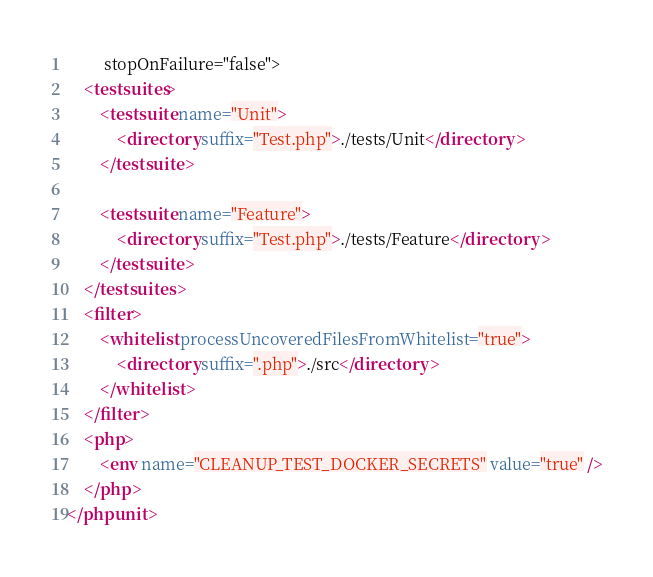Convert code to text. <code><loc_0><loc_0><loc_500><loc_500><_XML_>         stopOnFailure="false">
    <testsuites>
        <testsuite name="Unit">
            <directory suffix="Test.php">./tests/Unit</directory>
        </testsuite>

        <testsuite name="Feature">
            <directory suffix="Test.php">./tests/Feature</directory>
        </testsuite>
    </testsuites>
    <filter>
        <whitelist processUncoveredFilesFromWhitelist="true">
            <directory suffix=".php">./src</directory>
        </whitelist>
    </filter>
    <php>
        <env name="CLEANUP_TEST_DOCKER_SECRETS" value="true" />
    </php>
</phpunit>
</code> 